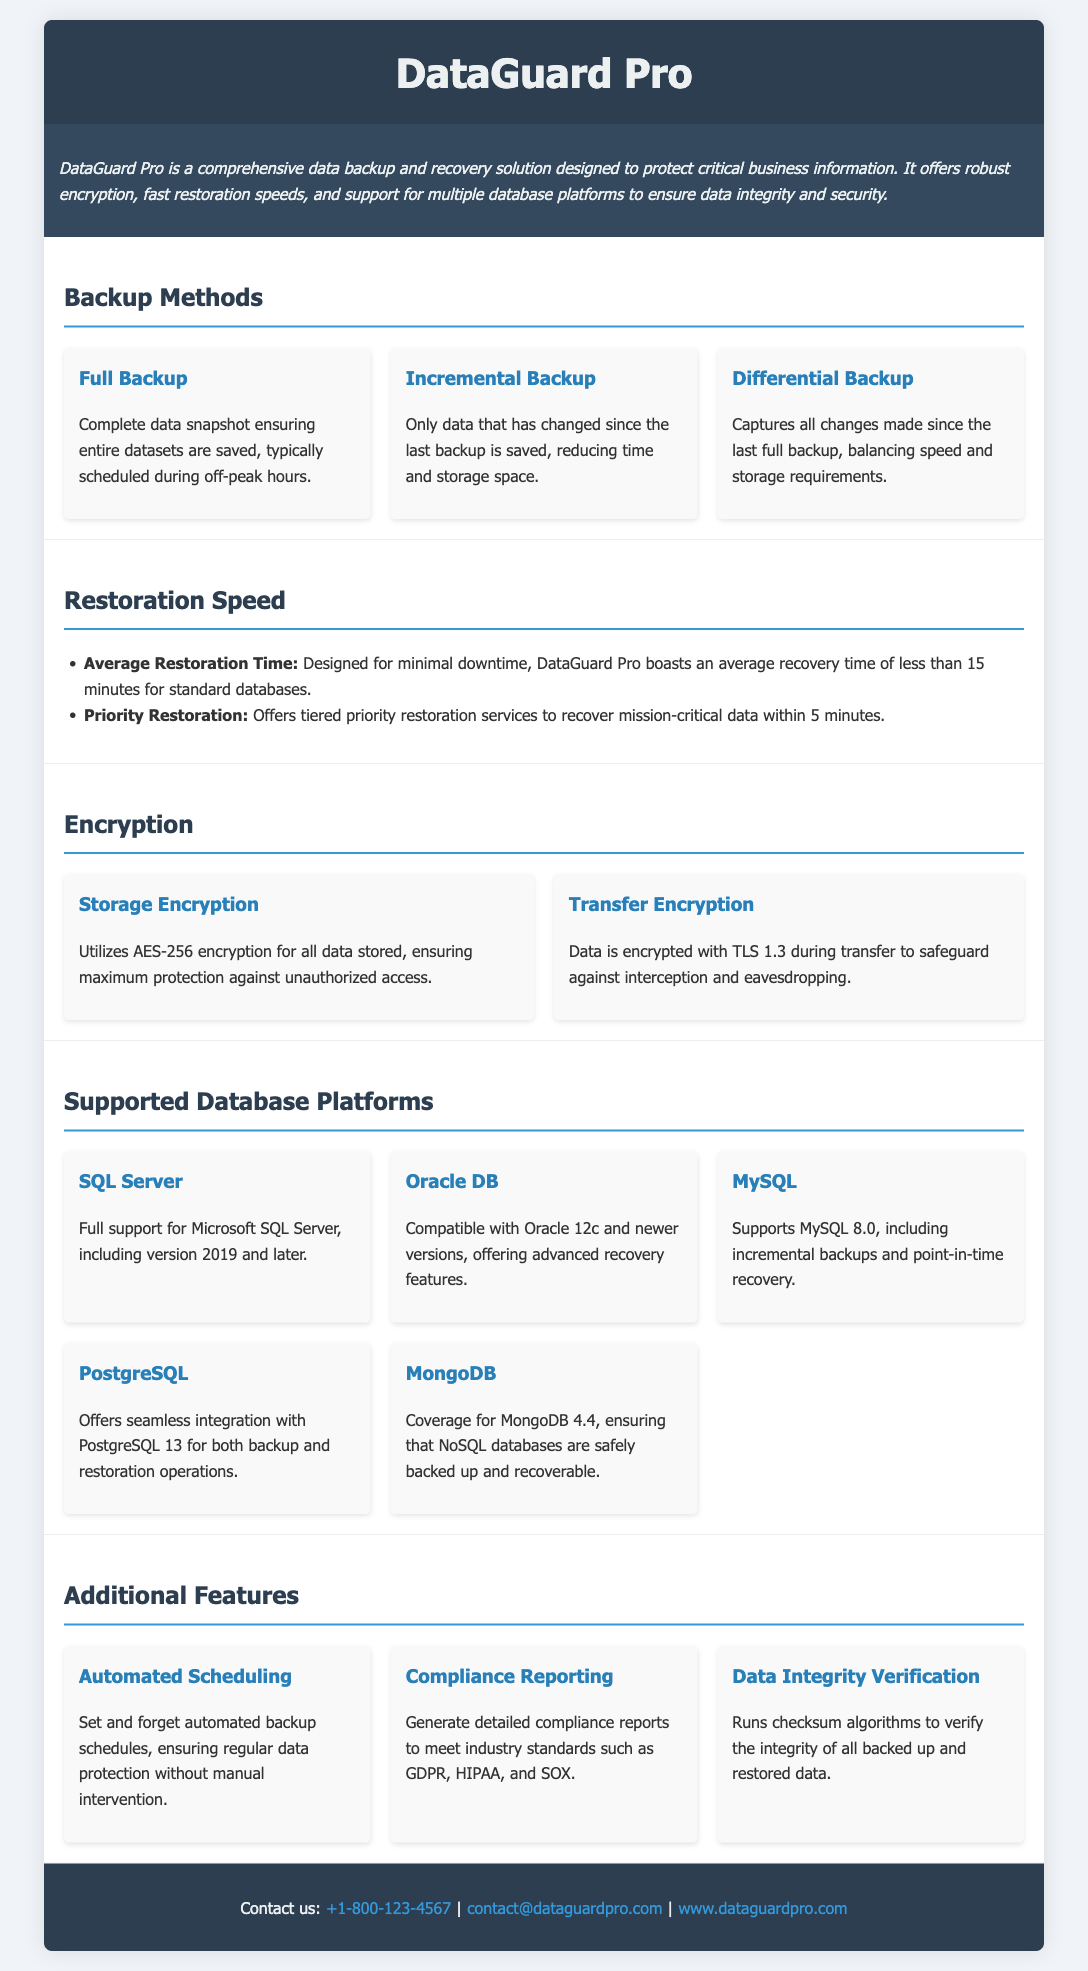What is the average restoration time? The average restoration time is less than 15 minutes for standard databases.
Answer: less than 15 minutes Which encryption method is used for stored data? The document states that AES-256 encryption is utilized for all data stored.
Answer: AES-256 What types of backup methods are mentioned? The product specification sheet lists Full Backup, Incremental Backup, and Differential Backup as backup methods.
Answer: Full Backup, Incremental Backup, Differential Backup Which database platform offers support for version 2019 and later? The document indicates that Microsoft SQL Server is supported, including version 2019 and later.
Answer: Microsoft SQL Server What is the priority restoration time for mission-critical data? The specification sheet mentions that priority restoration services can recover mission-critical data within 5 minutes.
Answer: 5 minutes Which encryption method is used during data transfer? The document specifies that data is encrypted with TLS 1.3 during transfer.
Answer: TLS 1.3 What feature allows automated backup scheduling? The specification sheet mentions "Automated Scheduling" as a feature that allows setting automated backup schedules.
Answer: Automated Scheduling How many database platforms does DataGuard Pro support? The document lists five database platforms: SQL Server, Oracle DB, MySQL, PostgreSQL, and MongoDB.
Answer: Five 